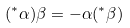<formula> <loc_0><loc_0><loc_500><loc_500>( ^ { * } \alpha ) \beta = - \alpha ( ^ { * } \beta )</formula> 